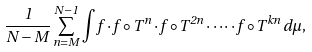<formula> <loc_0><loc_0><loc_500><loc_500>\frac { 1 } { N - M } \sum _ { n = M } ^ { N - 1 } \int f \cdot f \circ T ^ { n } \cdot f \circ T ^ { 2 n } \cdot \cdots \cdot f \circ T ^ { k n } \, d \mu ,</formula> 